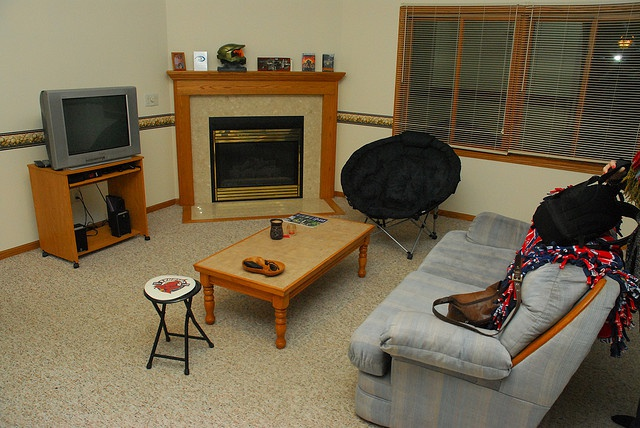Describe the objects in this image and their specific colors. I can see couch in darkgray, gray, and black tones, chair in darkgray, black, and gray tones, tv in darkgray, black, gray, and maroon tones, backpack in darkgray, black, tan, and maroon tones, and handbag in darkgray, black, maroon, and gray tones in this image. 